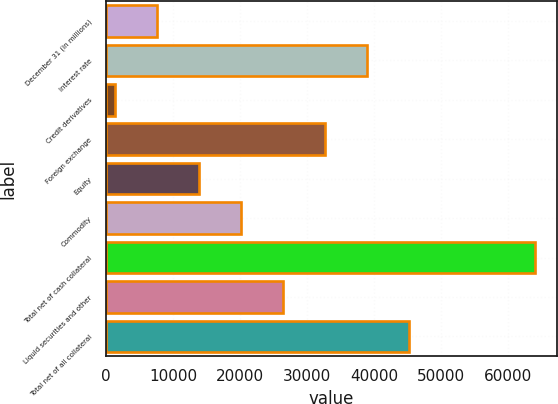Convert chart to OTSL. <chart><loc_0><loc_0><loc_500><loc_500><bar_chart><fcel>December 31 (in millions)<fcel>Interest rate<fcel>Credit derivatives<fcel>Foreign exchange<fcel>Equity<fcel>Commodity<fcel>Total net of cash collateral<fcel>Liquid securities and other<fcel>Total net of all collateral<nl><fcel>7572.4<fcel>38964.4<fcel>1294<fcel>32686<fcel>13850.8<fcel>20129.2<fcel>64078<fcel>26407.6<fcel>45242.8<nl></chart> 